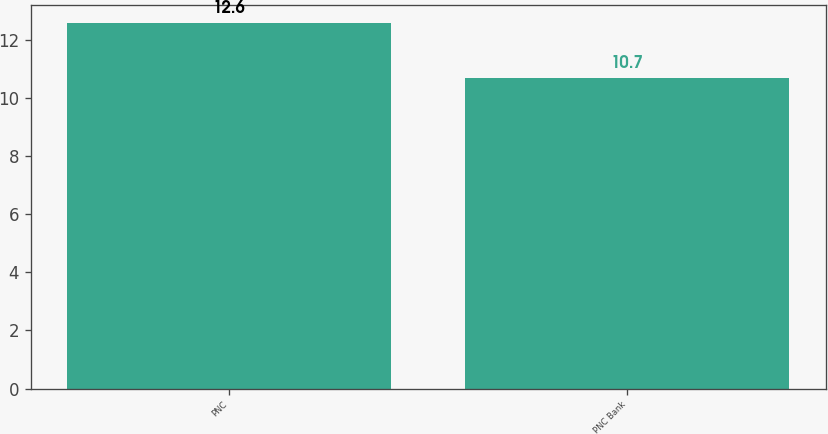Convert chart. <chart><loc_0><loc_0><loc_500><loc_500><bar_chart><fcel>PNC<fcel>PNC Bank<nl><fcel>12.6<fcel>10.7<nl></chart> 